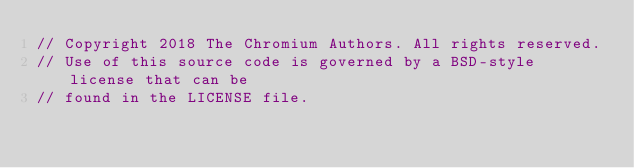<code> <loc_0><loc_0><loc_500><loc_500><_C++_>// Copyright 2018 The Chromium Authors. All rights reserved.
// Use of this source code is governed by a BSD-style license that can be
// found in the LICENSE file.
</code> 